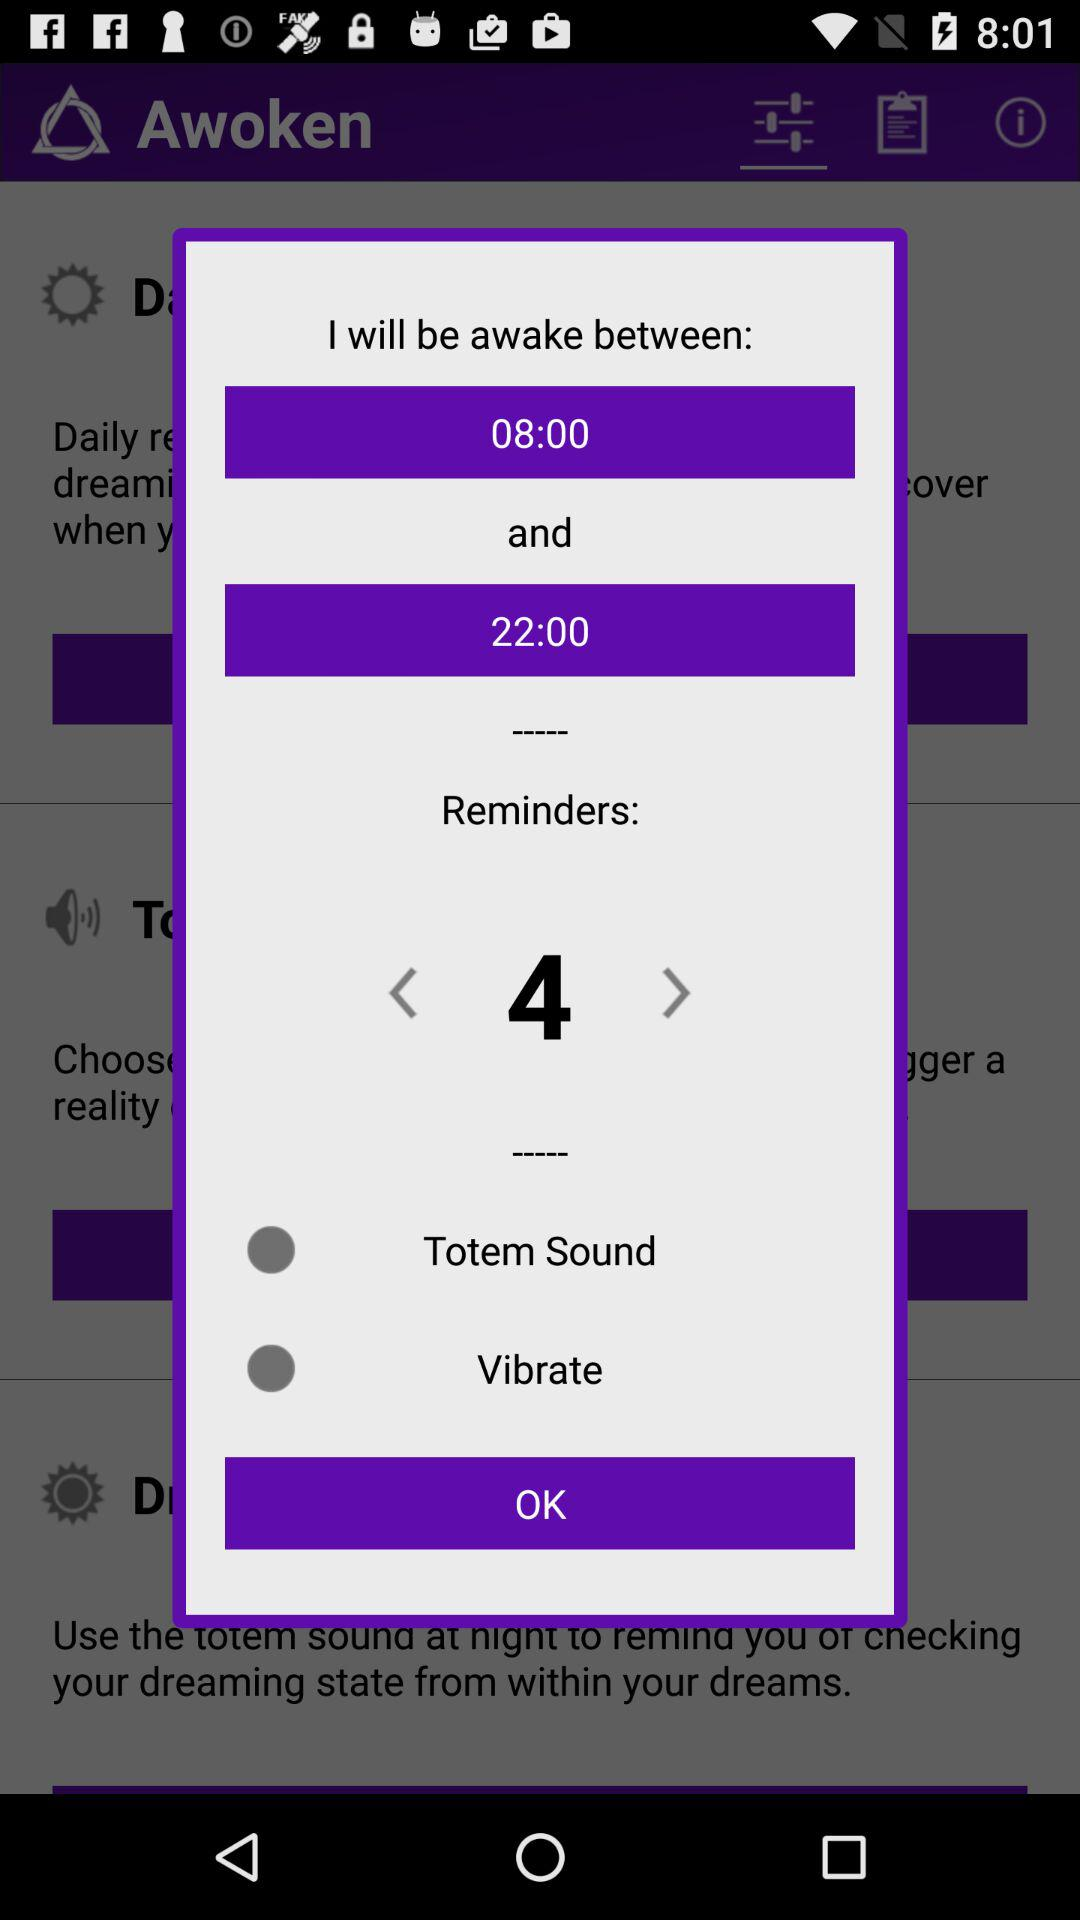How many reminders are set?
Answer the question using a single word or phrase. 4 